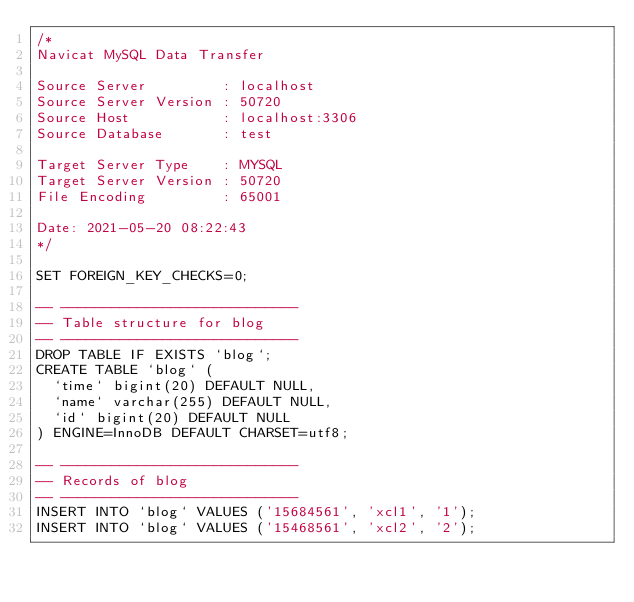<code> <loc_0><loc_0><loc_500><loc_500><_SQL_>/*
Navicat MySQL Data Transfer

Source Server         : localhost
Source Server Version : 50720
Source Host           : localhost:3306
Source Database       : test

Target Server Type    : MYSQL
Target Server Version : 50720
File Encoding         : 65001

Date: 2021-05-20 08:22:43
*/

SET FOREIGN_KEY_CHECKS=0;

-- ----------------------------
-- Table structure for blog
-- ----------------------------
DROP TABLE IF EXISTS `blog`;
CREATE TABLE `blog` (
  `time` bigint(20) DEFAULT NULL,
  `name` varchar(255) DEFAULT NULL,
  `id` bigint(20) DEFAULT NULL
) ENGINE=InnoDB DEFAULT CHARSET=utf8;

-- ----------------------------
-- Records of blog
-- ----------------------------
INSERT INTO `blog` VALUES ('15684561', 'xcl1', '1');
INSERT INTO `blog` VALUES ('15468561', 'xcl2', '2');
</code> 